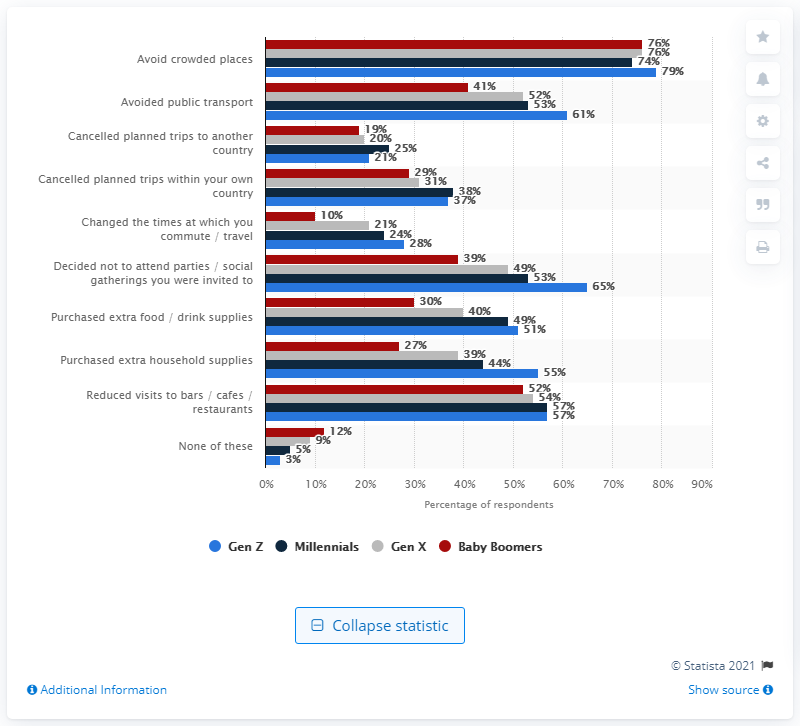Identify some key points in this picture. Baby Boomers are the most likely to have not taken any of the selected measures. 